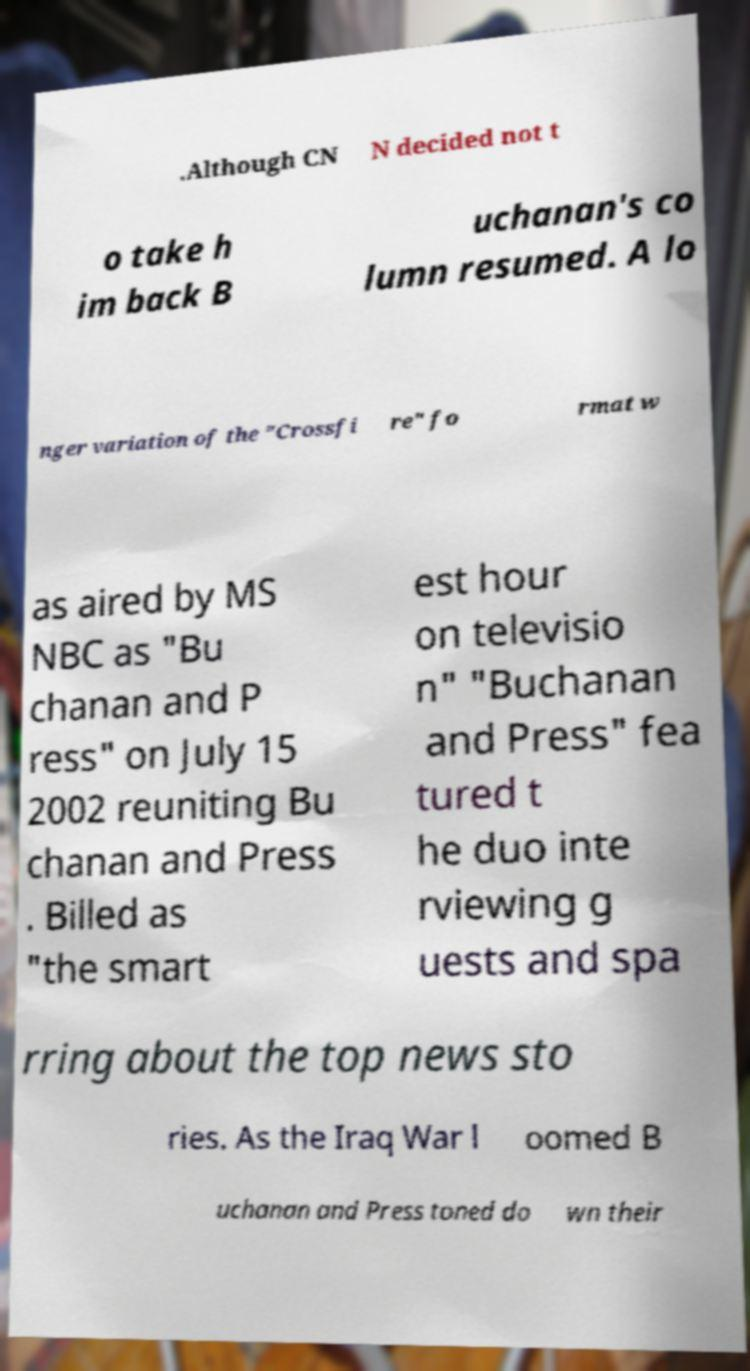What messages or text are displayed in this image? I need them in a readable, typed format. .Although CN N decided not t o take h im back B uchanan's co lumn resumed. A lo nger variation of the "Crossfi re" fo rmat w as aired by MS NBC as "Bu chanan and P ress" on July 15 2002 reuniting Bu chanan and Press . Billed as "the smart est hour on televisio n" "Buchanan and Press" fea tured t he duo inte rviewing g uests and spa rring about the top news sto ries. As the Iraq War l oomed B uchanan and Press toned do wn their 